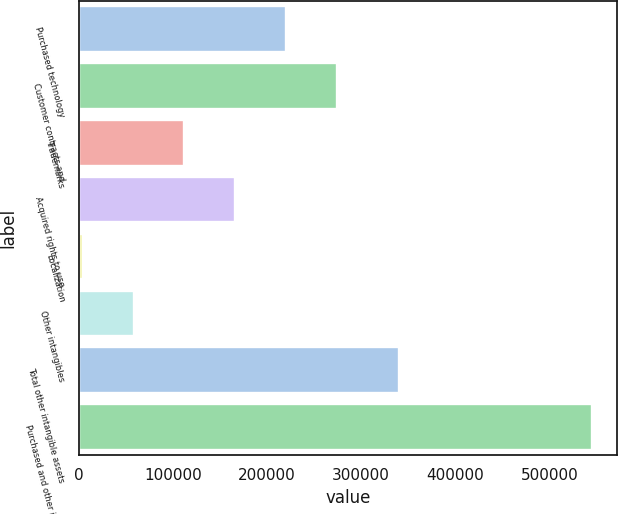Convert chart to OTSL. <chart><loc_0><loc_0><loc_500><loc_500><bar_chart><fcel>Purchased technology<fcel>Customer contracts and<fcel>Trademarks<fcel>Acquired rights to use<fcel>Localization<fcel>Other intangibles<fcel>Total other intangible assets<fcel>Purchased and other intangible<nl><fcel>220374<fcel>274484<fcel>112153<fcel>166263<fcel>3932<fcel>58042.4<fcel>340000<fcel>545036<nl></chart> 